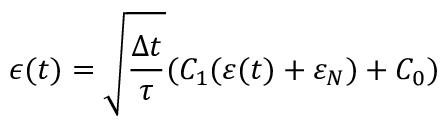<formula> <loc_0><loc_0><loc_500><loc_500>\epsilon ( t ) = \sqrt { \frac { \Delta t } { \tau } } ( C _ { 1 } ( \varepsilon ( t ) + \varepsilon _ { N } ) + C _ { 0 } )</formula> 